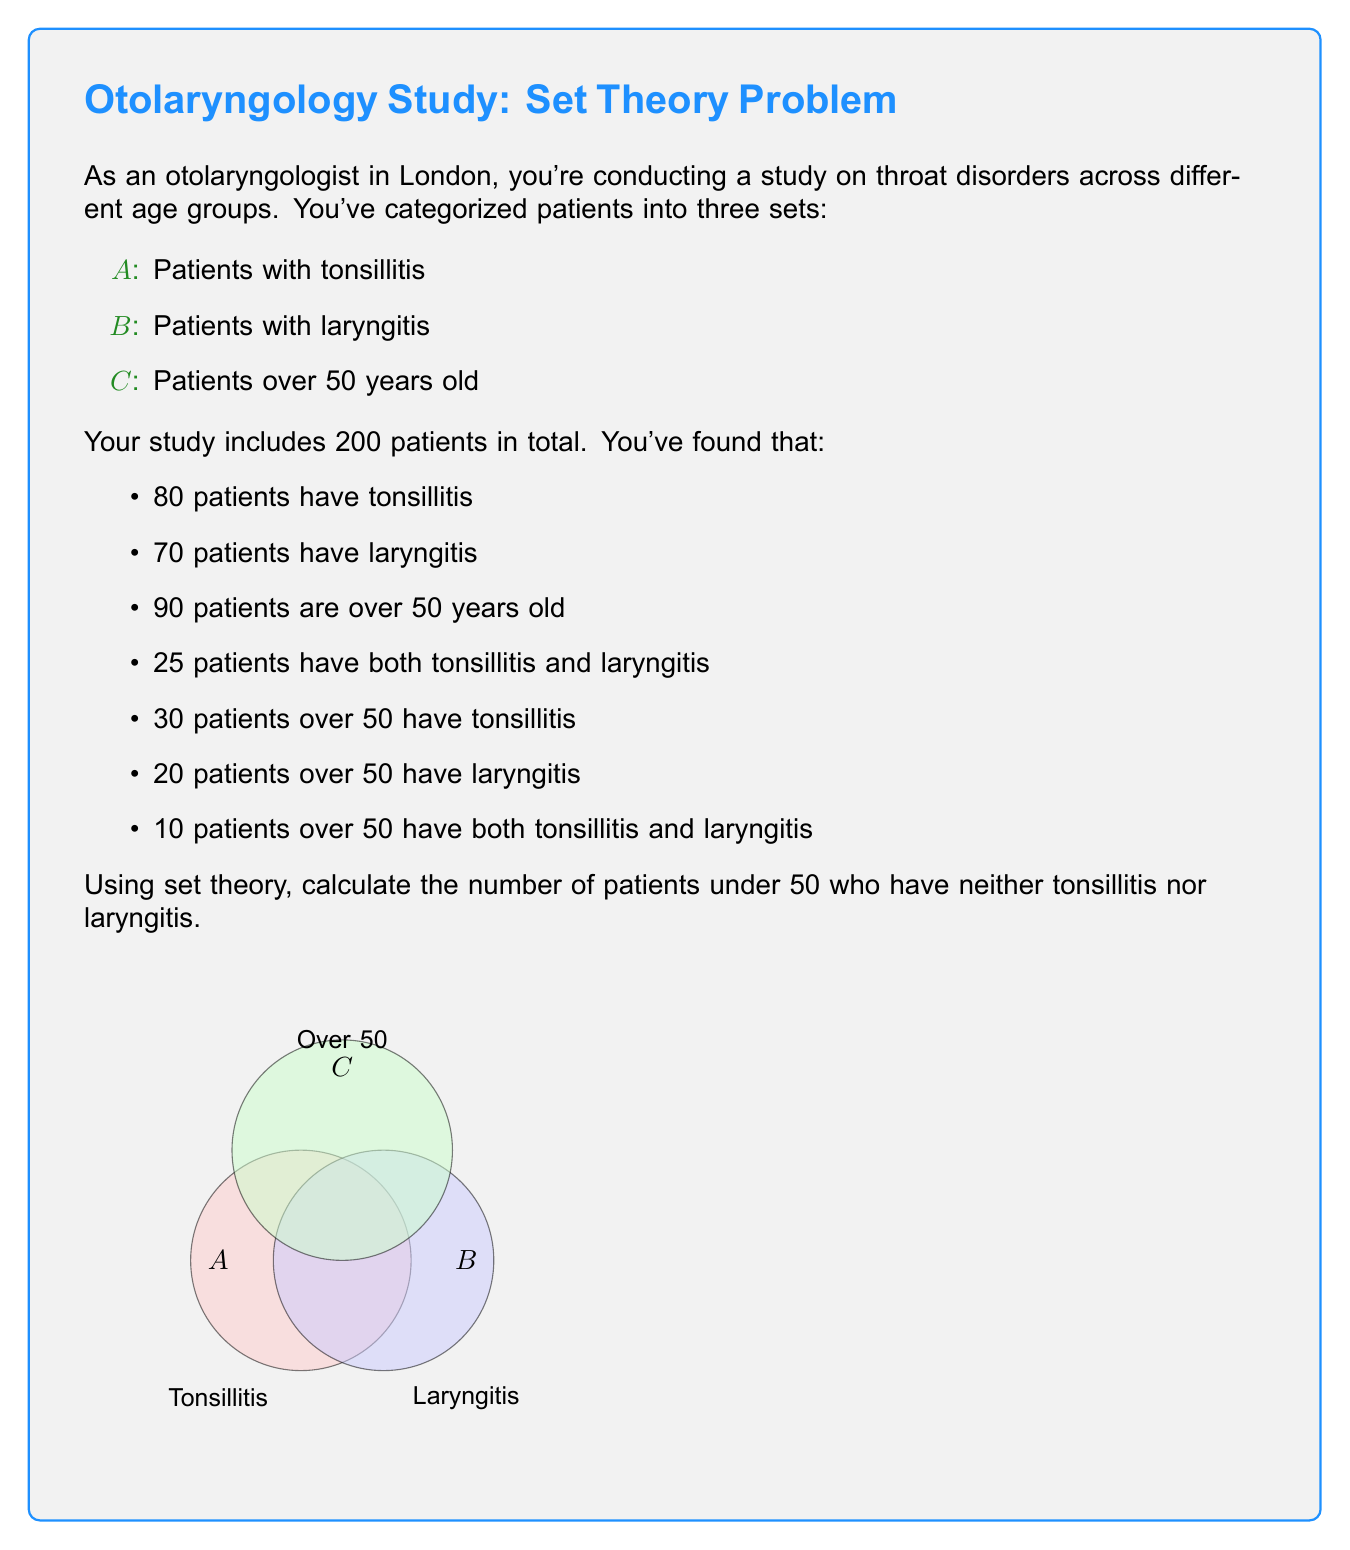Could you help me with this problem? Let's approach this step-by-step using set theory:

1) First, let's define the universal set U as all patients in the study. |U| = 200.

2) We need to find |U - (A ∪ B ∪ C)|, where:
   A: Patients with tonsillitis
   B: Patients with laryngitis
   C: Patients over 50

3) We can use the inclusion-exclusion principle:
   |A ∪ B ∪ C| = |A| + |B| + |C| - |A ∩ B| - |A ∩ C| - |B ∩ C| + |A ∩ B ∩ C|

4) We know:
   |A| = 80, |B| = 70, |C| = 90
   |A ∩ B| = 25
   |A ∩ C| = 30
   |B ∩ C| = 20
   |A ∩ B ∩ C| = 10

5) Substituting these values:
   |A ∪ B ∪ C| = 80 + 70 + 90 - 25 - 30 - 20 + 10 = 175

6) Therefore, the number of patients in none of these sets is:
   |U - (A ∪ B ∪ C)| = |U| - |A ∪ B ∪ C| = 200 - 175 = 25

7) However, this includes patients over 50. We need to subtract these:
   Patients over 50 with neither condition = |C| - (|A ∩ C| + |B ∩ C| - |A ∩ B ∩ C|)
                                           = 90 - (30 + 20 - 10) = 50

8) Therefore, patients under 50 with neither condition:
   25 - 50 = -25

9) The negative result indicates our initial assumption was incorrect. All 25 patients with neither condition must be under 50.
Answer: 25 